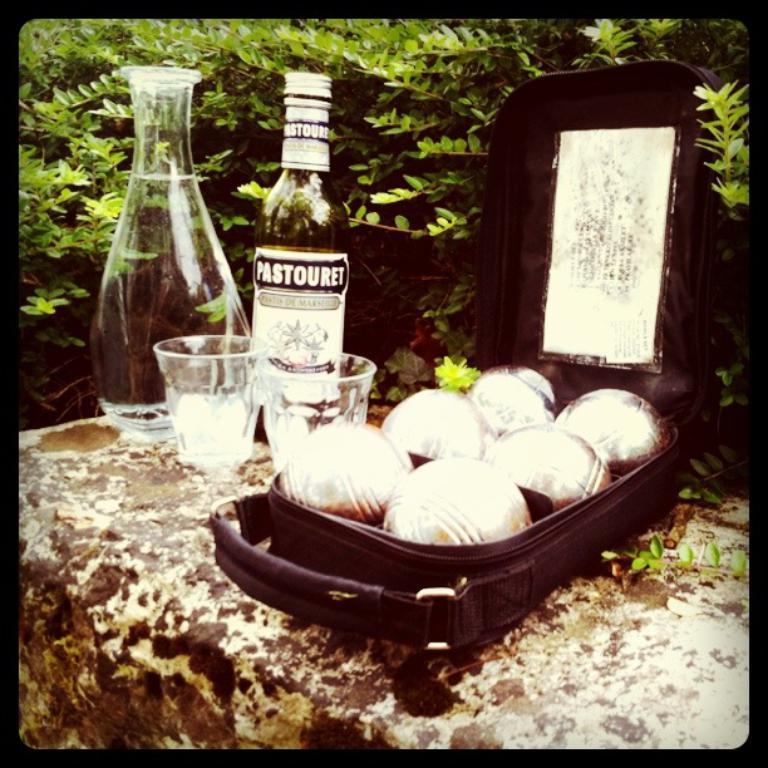Please provide a concise description of this image. This is a picture taken in the outdoors. On the wall there are jar, bottles, cups and a box with some food item. Behind the bottle there are trees. 